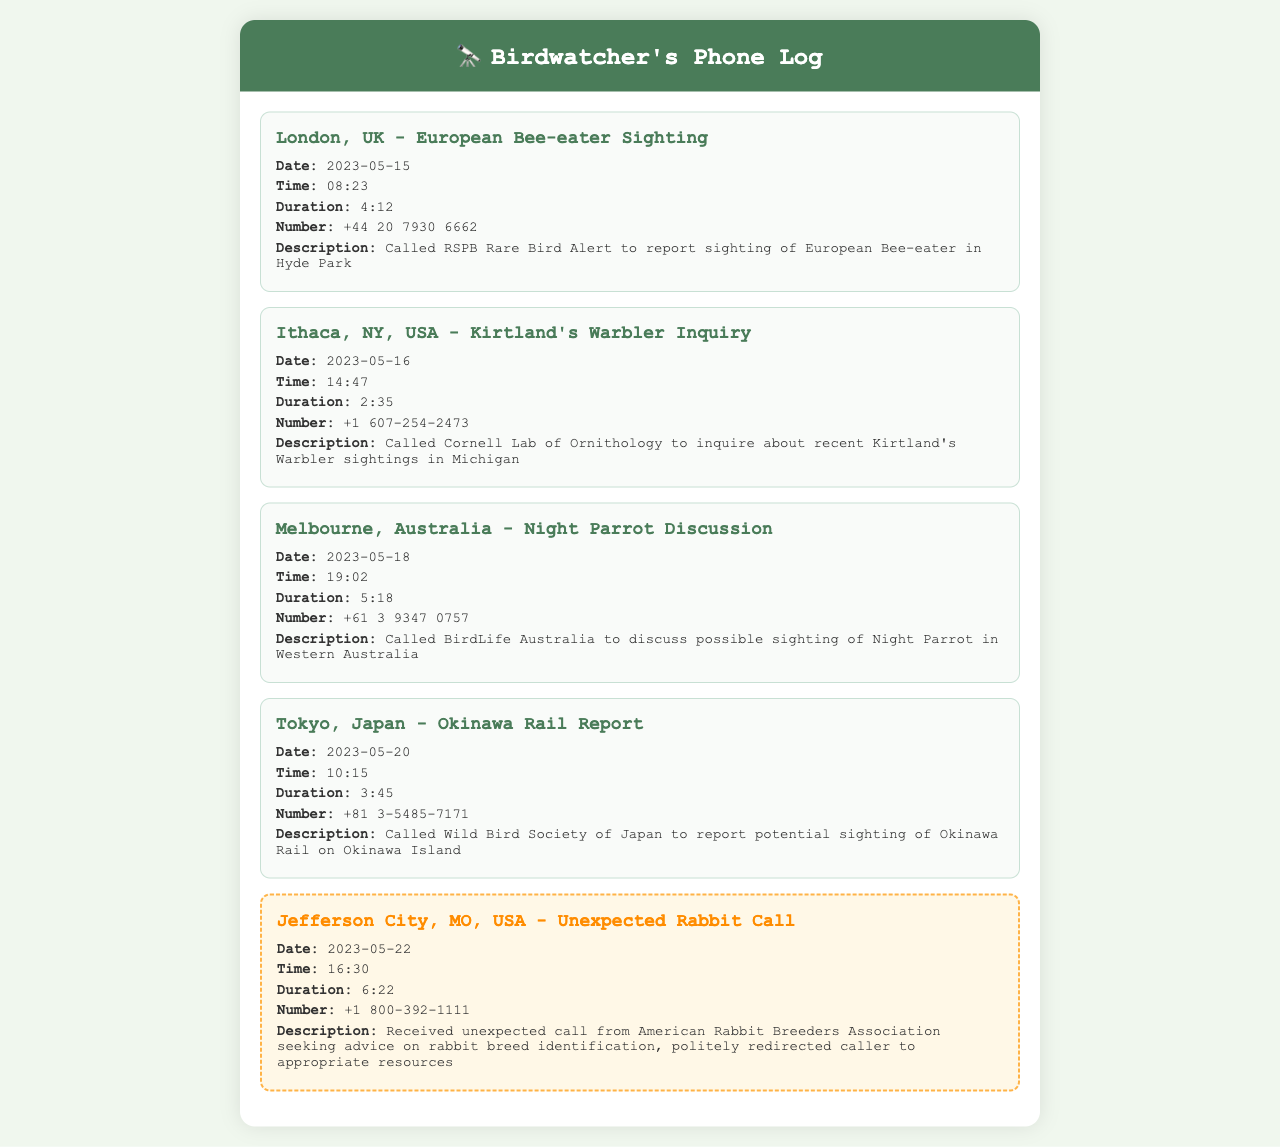what is the date of the European Bee-eater sighting? The date of the European Bee-eater sighting is mentioned in the document as 2023-05-15.
Answer: 2023-05-15 who did the caller contact about the Kirtland's Warbler inquiry? The caller contacted Cornell Lab of Ornithology about the Kirtland's Warbler inquiry.
Answer: Cornell Lab of Ornithology what was the duration of the call regarding the Night Parrot discussion? The duration of the call regarding the Night Parrot discussion is specified as 5:18.
Answer: 5:18 where was the unexpected rabbit call received from? The unexpected rabbit call was received from Jefferson City, MO, USA.
Answer: Jefferson City, MO, USA how many records in total are listed in the phone log? The total number of records in the phone log can be counted directly from the document, which shows five calls.
Answer: 5 what is the call duration of the Okinawa Rail report? The call duration of the Okinawa Rail report is given as 3:45.
Answer: 3:45 what number was called to discuss the possible sighting of the Night Parrot? The number called to discuss the possible sighting of the Night Parrot is mentioned as +61 3 9347 0757.
Answer: +61 3 9347 0757 what is the last call record's description? The last call record's description indicates a call regarding rabbit breed identification and being redirected.
Answer: Received unexpected call from American Rabbit Breeders Association seeking advice on rabbit breed identification, politely redirected caller to appropriate resources 